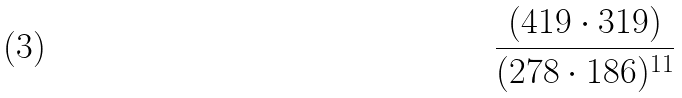Convert formula to latex. <formula><loc_0><loc_0><loc_500><loc_500>\frac { ( 4 1 9 \cdot 3 1 9 ) } { ( 2 7 8 \cdot 1 8 6 ) ^ { 1 1 } }</formula> 